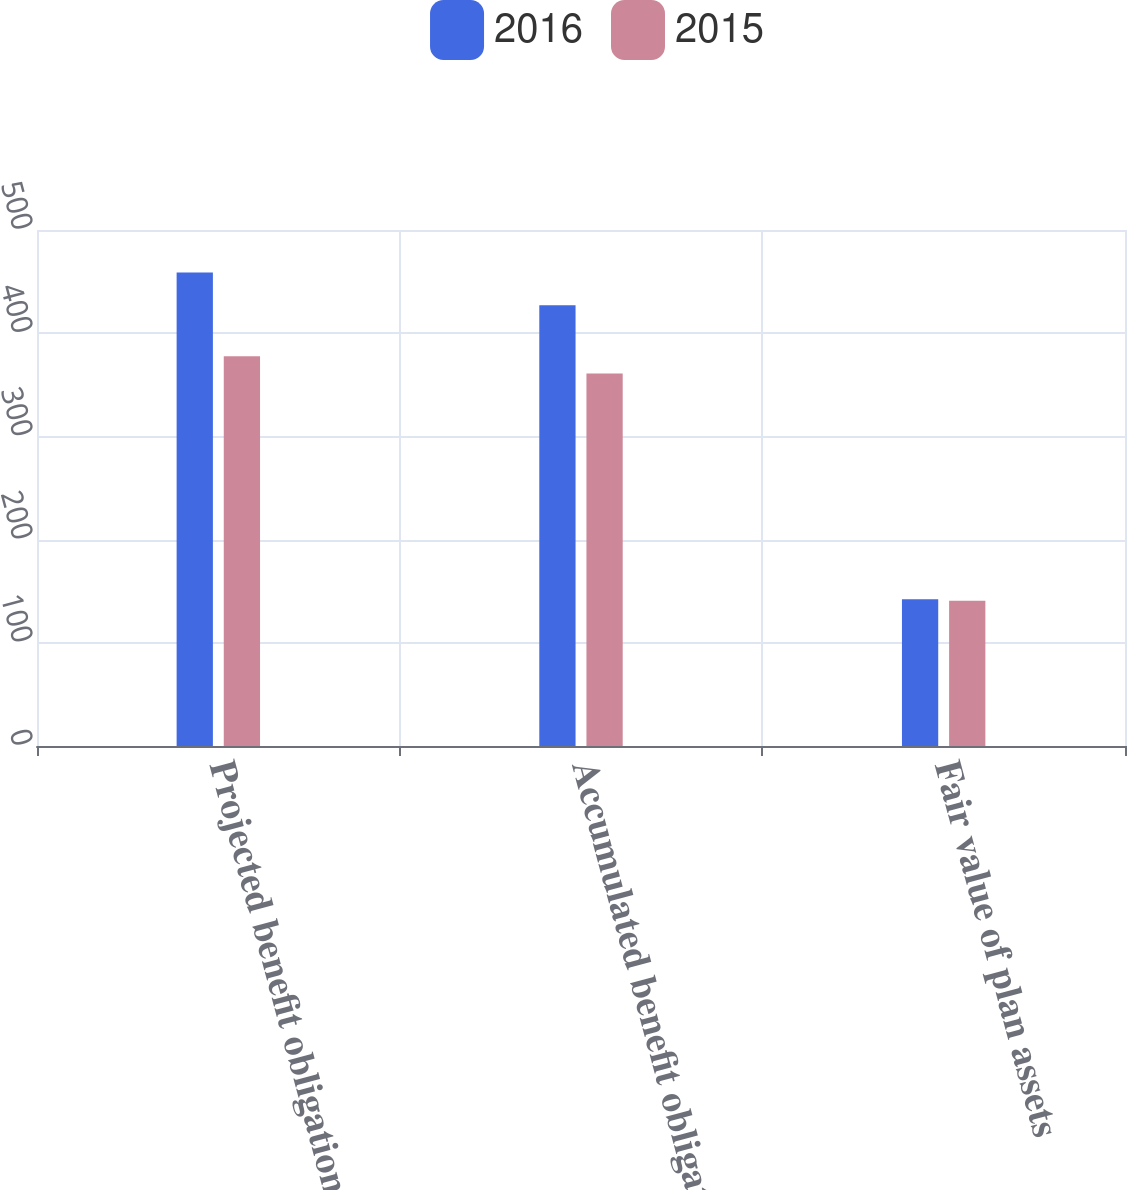<chart> <loc_0><loc_0><loc_500><loc_500><stacked_bar_chart><ecel><fcel>Projected benefit obligation<fcel>Accumulated benefit obligation<fcel>Fair value of plan assets<nl><fcel>2016<fcel>458.7<fcel>427.2<fcel>142.3<nl><fcel>2015<fcel>377.7<fcel>361<fcel>140.7<nl></chart> 